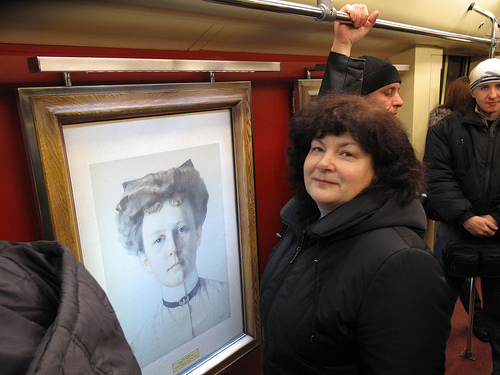<image>
Is there a woman in front of the painting? Yes. The woman is positioned in front of the painting, appearing closer to the camera viewpoint. 